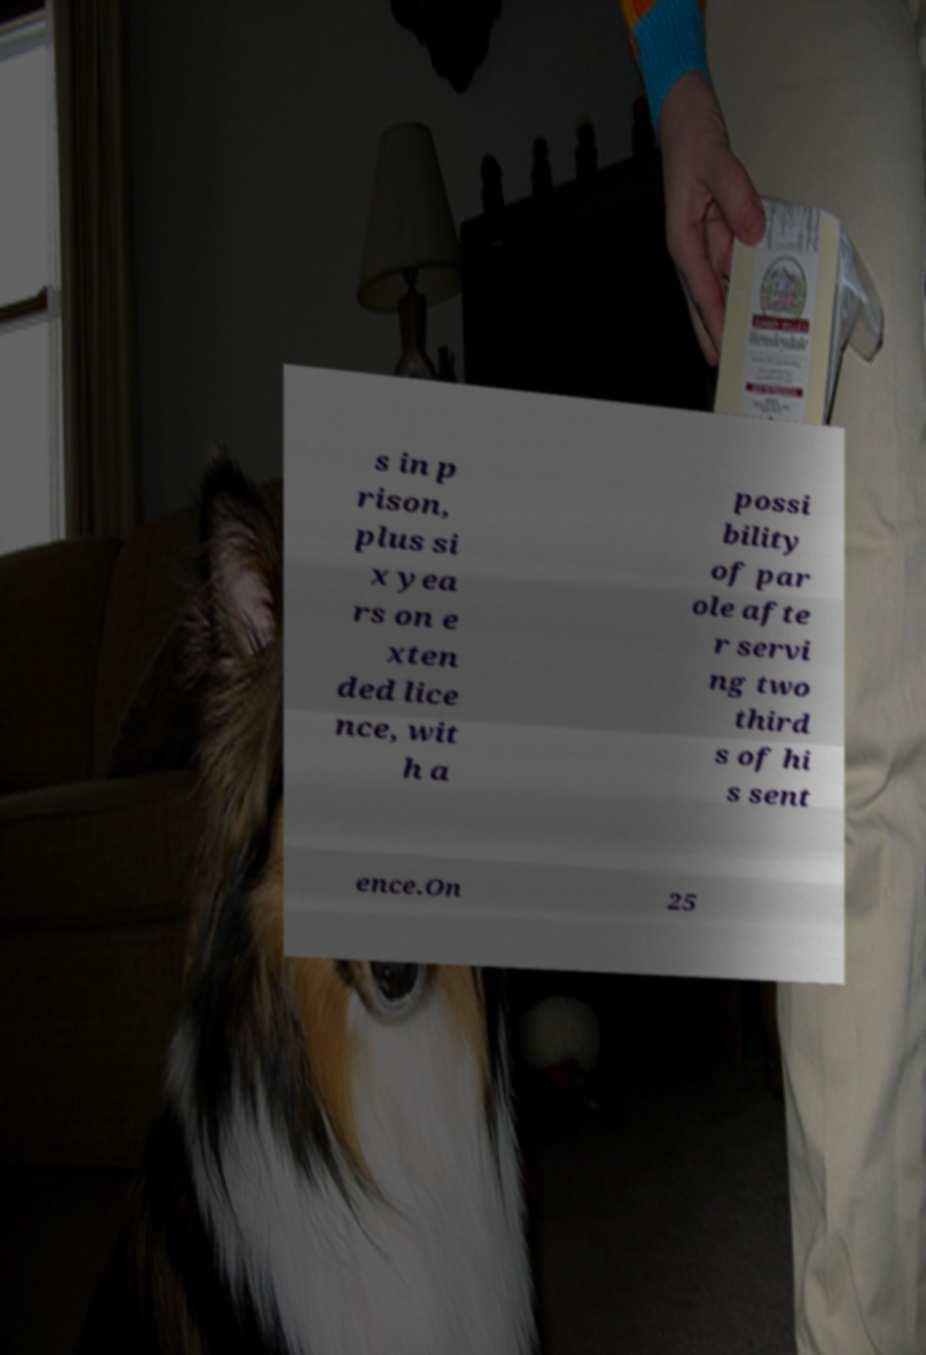Please identify and transcribe the text found in this image. s in p rison, plus si x yea rs on e xten ded lice nce, wit h a possi bility of par ole afte r servi ng two third s of hi s sent ence.On 25 